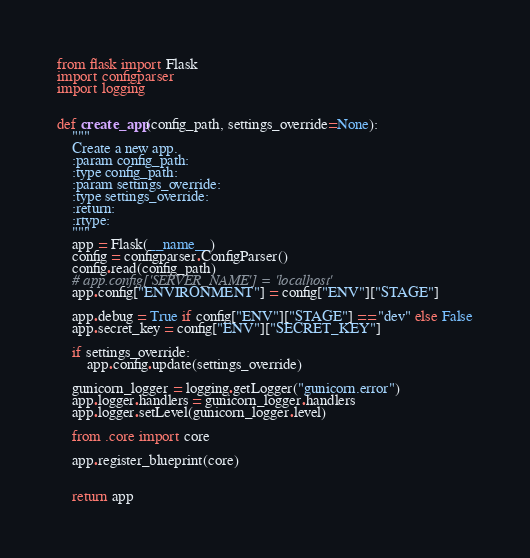<code> <loc_0><loc_0><loc_500><loc_500><_Python_>from flask import Flask
import configparser
import logging


def create_app(config_path, settings_override=None):
    """
    Create a new app.
    :param config_path:
    :type config_path:
    :param settings_override:
    :type settings_override:
    :return:
    :rtype:
    """
    app = Flask(__name__)
    config = configparser.ConfigParser()
    config.read(config_path)
    # app.config['SERVER_NAME'] = 'localhost'
    app.config["ENVIRONMENT"] = config["ENV"]["STAGE"]

    app.debug = True if config["ENV"]["STAGE"] == "dev" else False
    app.secret_key = config["ENV"]["SECRET_KEY"]

    if settings_override:
        app.config.update(settings_override)

    gunicorn_logger = logging.getLogger("gunicorn.error")
    app.logger.handlers = gunicorn_logger.handlers
    app.logger.setLevel(gunicorn_logger.level)

    from .core import core

    app.register_blueprint(core)


    return app
</code> 